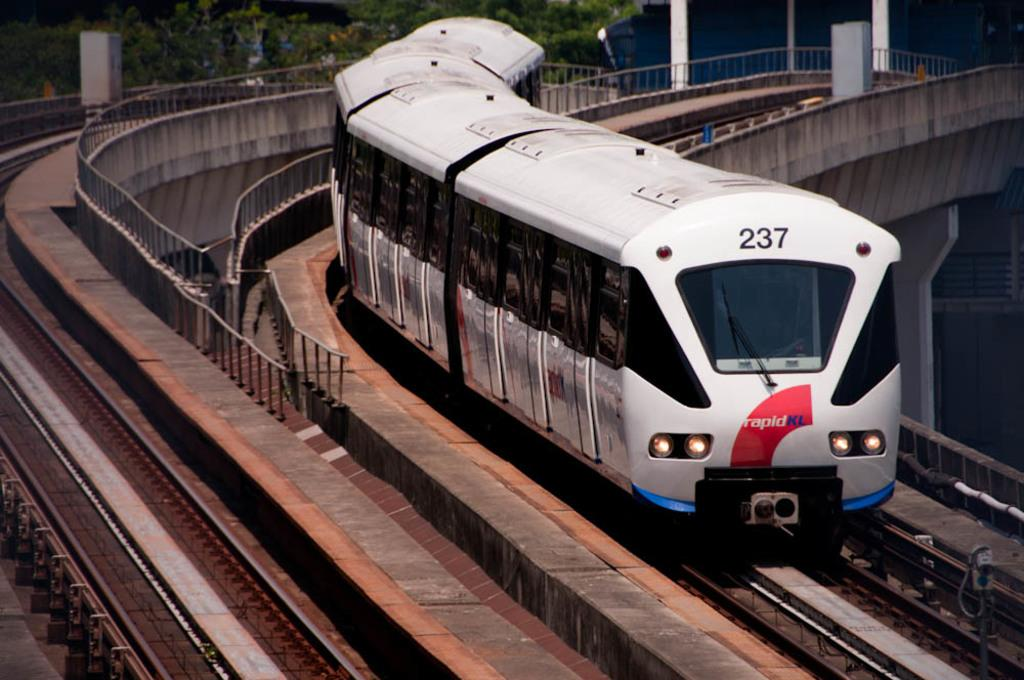Provide a one-sentence caption for the provided image. A train going down a track on an overpass with the number 237 in the front top of the train. 